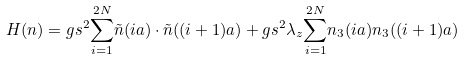Convert formula to latex. <formula><loc_0><loc_0><loc_500><loc_500>H ( { n } ) = g { s ^ { 2 } } { \sum _ { i = 1 } ^ { 2 N } } { \tilde { n } } ( i a ) \cdot { \tilde { n } } ( ( i + 1 ) a ) + g { s ^ { 2 } } { \lambda _ { z } } { \sum _ { i = 1 } ^ { 2 N } } { n _ { 3 } } ( i a ) { n _ { 3 } } ( ( i + 1 ) a )</formula> 